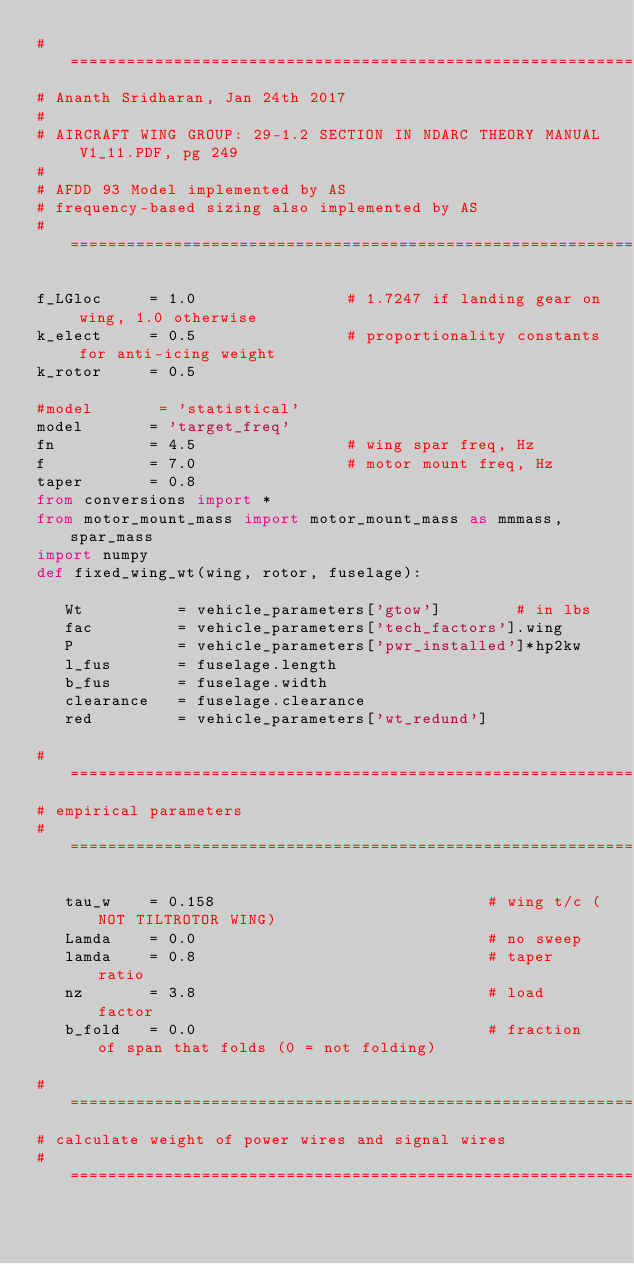Convert code to text. <code><loc_0><loc_0><loc_500><loc_500><_Python_>#====================================================================
# Ananth Sridharan, Jan 24th 2017
#
# AIRCRAFT WING GROUP: 29-1.2 SECTION IN NDARC THEORY MANUAL V1_11.PDF, pg 249
#
# AFDD 93 Model implemented by AS
# frequency-based sizing also implemented by AS
#====================================================================

f_LGloc     = 1.0                # 1.7247 if landing gear on wing, 1.0 otherwise
k_elect     = 0.5                # proportionality constants for anti-icing weight
k_rotor     = 0.5

#model       = 'statistical'
model       = 'target_freq'
fn          = 4.5                # wing spar freq, Hz
f           = 7.0                # motor mount freq, Hz
taper       = 0.8               
from conversions import *
from motor_mount_mass import motor_mount_mass as mmmass, spar_mass
import numpy
def fixed_wing_wt(wing, rotor, fuselage):

   Wt          = vehicle_parameters['gtow']        # in lbs
   fac         = vehicle_parameters['tech_factors'].wing
   P           = vehicle_parameters['pwr_installed']*hp2kw
   l_fus       = fuselage.length
   b_fus       = fuselage.width
   clearance   = fuselage.clearance
   red         = vehicle_parameters['wt_redund']

#====================================================================
# empirical parameters
#====================================================================

   tau_w    = 0.158                             # wing t/c (NOT TILTROTOR WING)
   Lamda    = 0.0                               # no sweep
   lamda    = 0.8                               # taper ratio
   nz       = 3.8                               # load factor 
   b_fold   = 0.0                               # fraction of span that folds (0 = not folding)

#====================================================================
# calculate weight of power wires and signal wires
#====================================================================
   </code> 